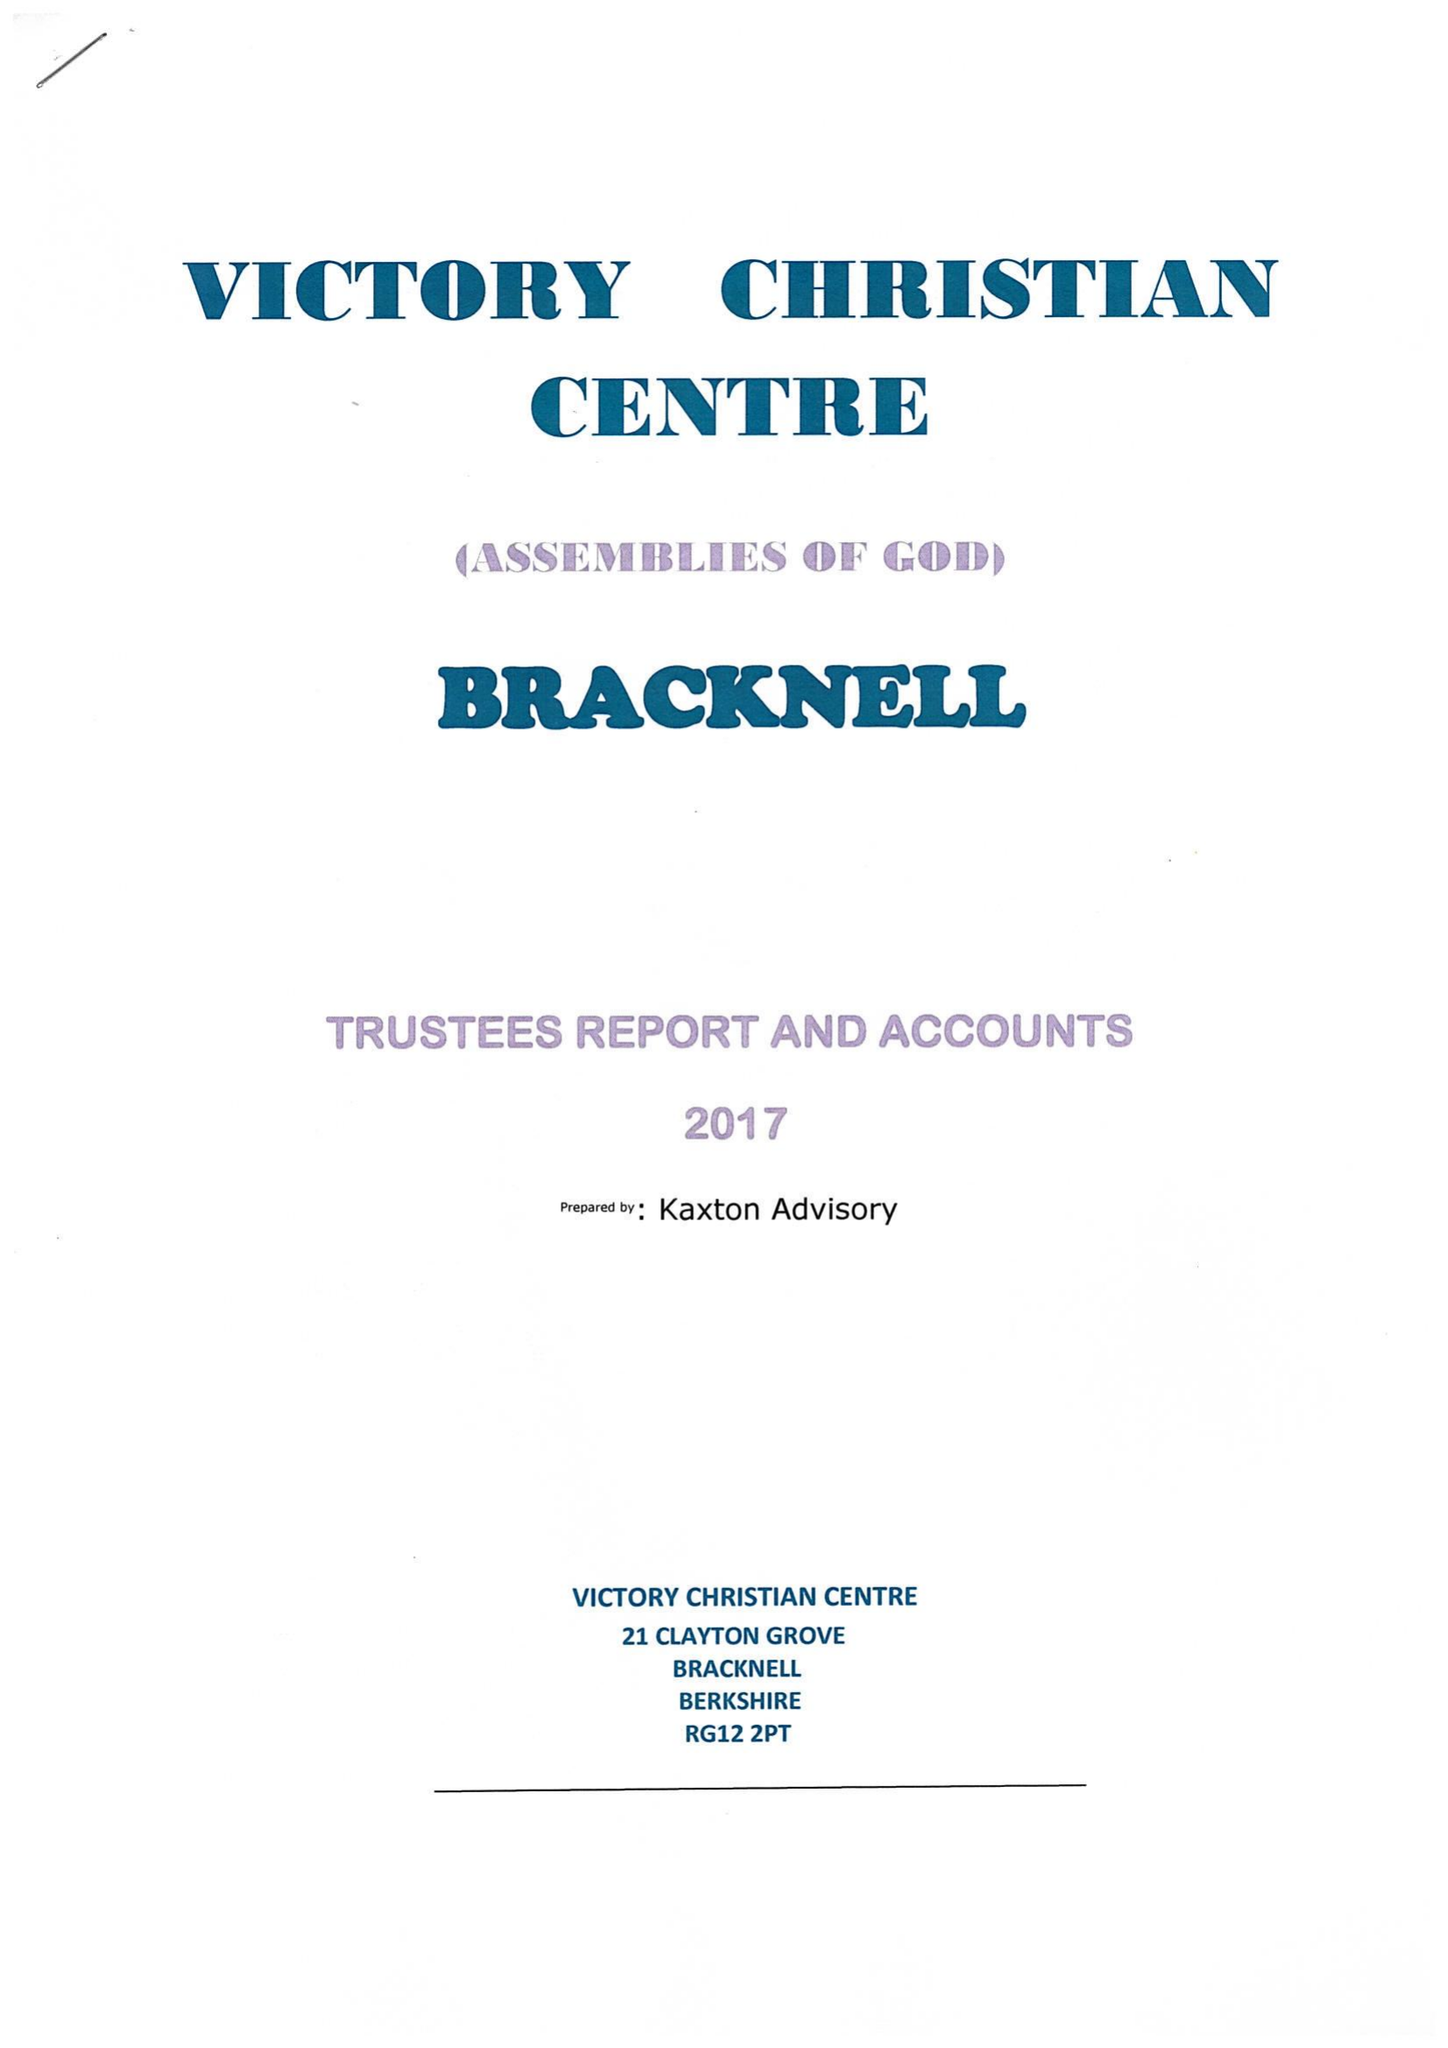What is the value for the spending_annually_in_british_pounds?
Answer the question using a single word or phrase. 37559.00 